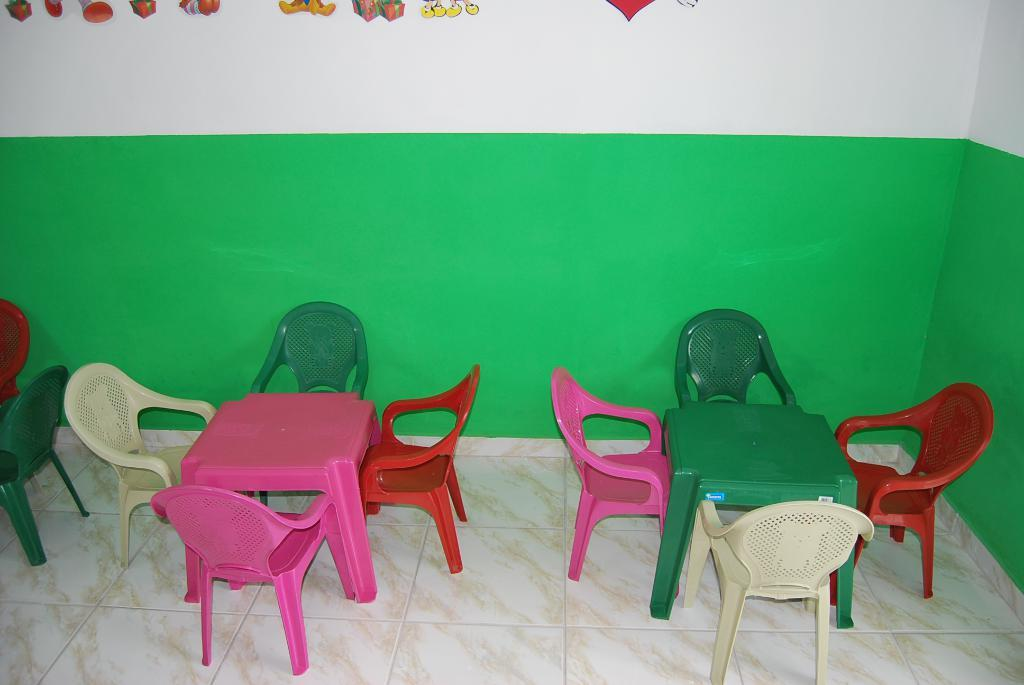What type of furniture is present in the image? There are chairs in the image. Can you describe the appearance of the chairs? The chairs are in multiple colors. What can be seen in the background of the image? There is a wall in the background of the image. What colors are present on the wall? The wall has green and white colors. What type of liquid is being poured from the stem in the image? There is no stem or liquid present in the image; it features chairs and a wall with green and white colors. 